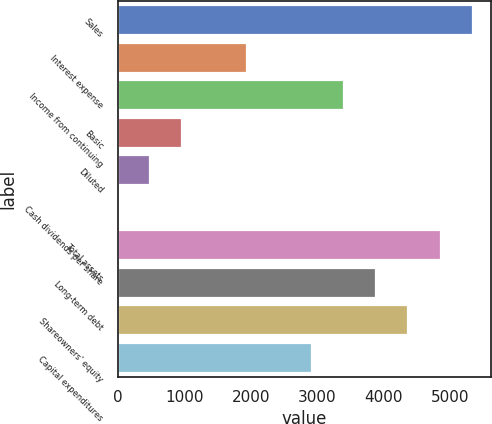Convert chart. <chart><loc_0><loc_0><loc_500><loc_500><bar_chart><fcel>Sales<fcel>Interest expense<fcel>Income from continuing<fcel>Basic<fcel>Diluted<fcel>Cash dividends per share<fcel>Total assets<fcel>Long-term debt<fcel>Shareowners' equity<fcel>Capital expenditures<nl><fcel>5342.6<fcel>1943.54<fcel>3400.28<fcel>972.38<fcel>486.8<fcel>1.22<fcel>4857.02<fcel>3885.86<fcel>4371.44<fcel>2914.7<nl></chart> 